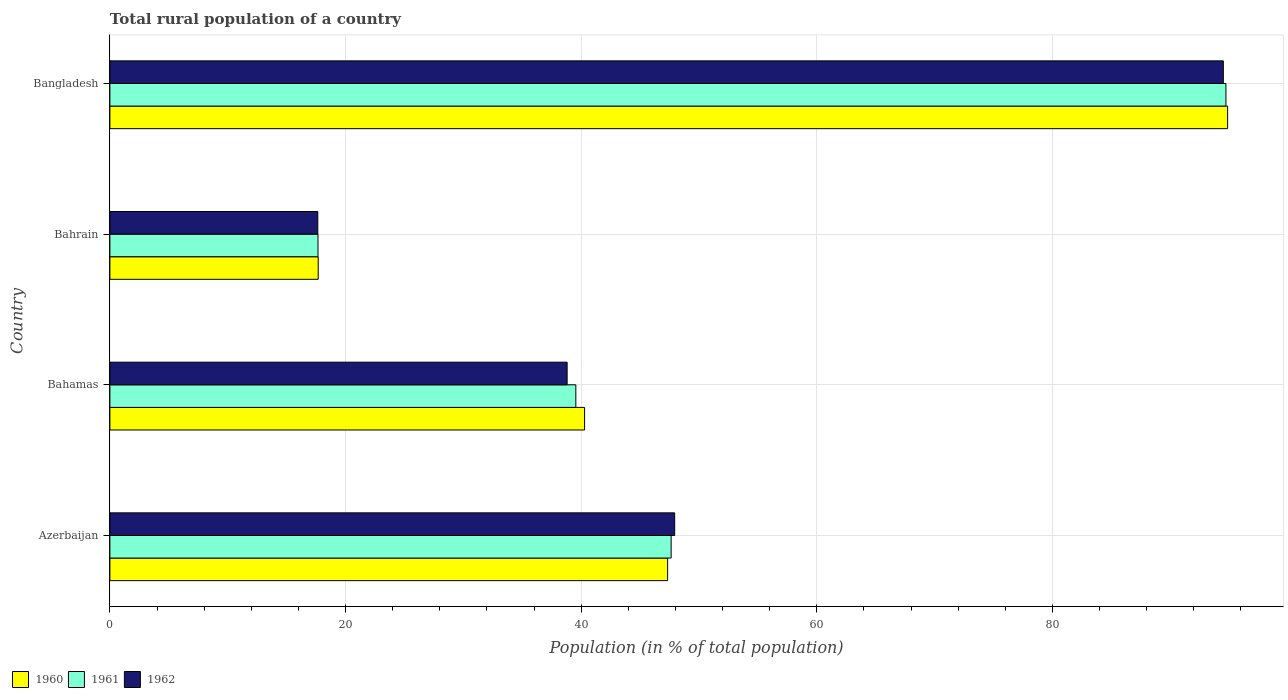How many different coloured bars are there?
Give a very brief answer. 3. How many groups of bars are there?
Keep it short and to the point. 4. Are the number of bars per tick equal to the number of legend labels?
Offer a terse response. Yes. How many bars are there on the 3rd tick from the top?
Provide a short and direct response. 3. How many bars are there on the 2nd tick from the bottom?
Your response must be concise. 3. What is the label of the 3rd group of bars from the top?
Provide a succinct answer. Bahamas. What is the rural population in 1961 in Azerbaijan?
Ensure brevity in your answer.  47.64. Across all countries, what is the maximum rural population in 1962?
Your answer should be very brief. 94.5. Across all countries, what is the minimum rural population in 1962?
Make the answer very short. 17.64. In which country was the rural population in 1960 minimum?
Your response must be concise. Bahrain. What is the total rural population in 1960 in the graph?
Your response must be concise. 200.17. What is the difference between the rural population in 1960 in Bahamas and that in Bahrain?
Provide a short and direct response. 22.61. What is the difference between the rural population in 1962 in Bahamas and the rural population in 1961 in Bahrain?
Your answer should be compact. 21.14. What is the average rural population in 1961 per country?
Offer a terse response. 49.89. What is the difference between the rural population in 1961 and rural population in 1960 in Azerbaijan?
Offer a terse response. 0.3. In how many countries, is the rural population in 1962 greater than 48 %?
Ensure brevity in your answer.  1. What is the ratio of the rural population in 1961 in Bahamas to that in Bahrain?
Keep it short and to the point. 2.24. Is the rural population in 1962 in Bahamas less than that in Bangladesh?
Provide a succinct answer. Yes. Is the difference between the rural population in 1961 in Bahamas and Bangladesh greater than the difference between the rural population in 1960 in Bahamas and Bangladesh?
Your answer should be compact. No. What is the difference between the highest and the second highest rural population in 1961?
Your response must be concise. 47.09. What is the difference between the highest and the lowest rural population in 1962?
Your response must be concise. 76.86. In how many countries, is the rural population in 1960 greater than the average rural population in 1960 taken over all countries?
Make the answer very short. 1. Is the sum of the rural population in 1960 in Bahrain and Bangladesh greater than the maximum rural population in 1962 across all countries?
Your answer should be very brief. Yes. Is it the case that in every country, the sum of the rural population in 1962 and rural population in 1960 is greater than the rural population in 1961?
Make the answer very short. Yes. Are all the bars in the graph horizontal?
Keep it short and to the point. Yes. Are the values on the major ticks of X-axis written in scientific E-notation?
Ensure brevity in your answer.  No. How are the legend labels stacked?
Offer a terse response. Horizontal. What is the title of the graph?
Provide a succinct answer. Total rural population of a country. Does "1975" appear as one of the legend labels in the graph?
Offer a very short reply. No. What is the label or title of the X-axis?
Ensure brevity in your answer.  Population (in % of total population). What is the label or title of the Y-axis?
Offer a very short reply. Country. What is the Population (in % of total population) in 1960 in Azerbaijan?
Make the answer very short. 47.34. What is the Population (in % of total population) in 1961 in Azerbaijan?
Keep it short and to the point. 47.64. What is the Population (in % of total population) in 1962 in Azerbaijan?
Make the answer very short. 47.94. What is the Population (in % of total population) in 1960 in Bahamas?
Ensure brevity in your answer.  40.29. What is the Population (in % of total population) in 1961 in Bahamas?
Make the answer very short. 39.55. What is the Population (in % of total population) in 1962 in Bahamas?
Offer a very short reply. 38.81. What is the Population (in % of total population) in 1960 in Bahrain?
Offer a terse response. 17.68. What is the Population (in % of total population) in 1961 in Bahrain?
Your answer should be very brief. 17.66. What is the Population (in % of total population) of 1962 in Bahrain?
Give a very brief answer. 17.64. What is the Population (in % of total population) of 1960 in Bangladesh?
Your response must be concise. 94.86. What is the Population (in % of total population) in 1961 in Bangladesh?
Your answer should be very brief. 94.72. What is the Population (in % of total population) of 1962 in Bangladesh?
Provide a short and direct response. 94.5. Across all countries, what is the maximum Population (in % of total population) of 1960?
Make the answer very short. 94.86. Across all countries, what is the maximum Population (in % of total population) of 1961?
Provide a succinct answer. 94.72. Across all countries, what is the maximum Population (in % of total population) of 1962?
Your answer should be compact. 94.5. Across all countries, what is the minimum Population (in % of total population) of 1960?
Your response must be concise. 17.68. Across all countries, what is the minimum Population (in % of total population) of 1961?
Provide a succinct answer. 17.66. Across all countries, what is the minimum Population (in % of total population) in 1962?
Offer a very short reply. 17.64. What is the total Population (in % of total population) of 1960 in the graph?
Provide a succinct answer. 200.17. What is the total Population (in % of total population) in 1961 in the graph?
Give a very brief answer. 199.57. What is the total Population (in % of total population) in 1962 in the graph?
Give a very brief answer. 198.89. What is the difference between the Population (in % of total population) of 1960 in Azerbaijan and that in Bahamas?
Offer a terse response. 7.05. What is the difference between the Population (in % of total population) of 1961 in Azerbaijan and that in Bahamas?
Your answer should be compact. 8.09. What is the difference between the Population (in % of total population) of 1962 in Azerbaijan and that in Bahamas?
Provide a short and direct response. 9.13. What is the difference between the Population (in % of total population) in 1960 in Azerbaijan and that in Bahrain?
Give a very brief answer. 29.66. What is the difference between the Population (in % of total population) of 1961 in Azerbaijan and that in Bahrain?
Ensure brevity in your answer.  29.97. What is the difference between the Population (in % of total population) of 1962 in Azerbaijan and that in Bahrain?
Your answer should be compact. 30.29. What is the difference between the Population (in % of total population) in 1960 in Azerbaijan and that in Bangladesh?
Provide a succinct answer. -47.53. What is the difference between the Population (in % of total population) of 1961 in Azerbaijan and that in Bangladesh?
Your response must be concise. -47.09. What is the difference between the Population (in % of total population) in 1962 in Azerbaijan and that in Bangladesh?
Your answer should be very brief. -46.57. What is the difference between the Population (in % of total population) in 1960 in Bahamas and that in Bahrain?
Provide a short and direct response. 22.61. What is the difference between the Population (in % of total population) in 1961 in Bahamas and that in Bahrain?
Provide a succinct answer. 21.88. What is the difference between the Population (in % of total population) in 1962 in Bahamas and that in Bahrain?
Provide a succinct answer. 21.16. What is the difference between the Population (in % of total population) of 1960 in Bahamas and that in Bangladesh?
Offer a terse response. -54.58. What is the difference between the Population (in % of total population) in 1961 in Bahamas and that in Bangladesh?
Keep it short and to the point. -55.18. What is the difference between the Population (in % of total population) in 1962 in Bahamas and that in Bangladesh?
Offer a terse response. -55.7. What is the difference between the Population (in % of total population) in 1960 in Bahrain and that in Bangladesh?
Offer a terse response. -77.19. What is the difference between the Population (in % of total population) in 1961 in Bahrain and that in Bangladesh?
Provide a short and direct response. -77.06. What is the difference between the Population (in % of total population) of 1962 in Bahrain and that in Bangladesh?
Give a very brief answer. -76.86. What is the difference between the Population (in % of total population) in 1960 in Azerbaijan and the Population (in % of total population) in 1961 in Bahamas?
Offer a terse response. 7.79. What is the difference between the Population (in % of total population) in 1960 in Azerbaijan and the Population (in % of total population) in 1962 in Bahamas?
Give a very brief answer. 8.53. What is the difference between the Population (in % of total population) of 1961 in Azerbaijan and the Population (in % of total population) of 1962 in Bahamas?
Your answer should be very brief. 8.83. What is the difference between the Population (in % of total population) in 1960 in Azerbaijan and the Population (in % of total population) in 1961 in Bahrain?
Provide a short and direct response. 29.67. What is the difference between the Population (in % of total population) of 1960 in Azerbaijan and the Population (in % of total population) of 1962 in Bahrain?
Your answer should be compact. 29.69. What is the difference between the Population (in % of total population) in 1961 in Azerbaijan and the Population (in % of total population) in 1962 in Bahrain?
Provide a short and direct response. 29.99. What is the difference between the Population (in % of total population) of 1960 in Azerbaijan and the Population (in % of total population) of 1961 in Bangladesh?
Your answer should be very brief. -47.38. What is the difference between the Population (in % of total population) in 1960 in Azerbaijan and the Population (in % of total population) in 1962 in Bangladesh?
Give a very brief answer. -47.16. What is the difference between the Population (in % of total population) in 1961 in Azerbaijan and the Population (in % of total population) in 1962 in Bangladesh?
Make the answer very short. -46.87. What is the difference between the Population (in % of total population) of 1960 in Bahamas and the Population (in % of total population) of 1961 in Bahrain?
Your answer should be very brief. 22.62. What is the difference between the Population (in % of total population) in 1960 in Bahamas and the Population (in % of total population) in 1962 in Bahrain?
Your response must be concise. 22.64. What is the difference between the Population (in % of total population) in 1961 in Bahamas and the Population (in % of total population) in 1962 in Bahrain?
Provide a short and direct response. 21.9. What is the difference between the Population (in % of total population) in 1960 in Bahamas and the Population (in % of total population) in 1961 in Bangladesh?
Your answer should be compact. -54.43. What is the difference between the Population (in % of total population) of 1960 in Bahamas and the Population (in % of total population) of 1962 in Bangladesh?
Provide a succinct answer. -54.21. What is the difference between the Population (in % of total population) of 1961 in Bahamas and the Population (in % of total population) of 1962 in Bangladesh?
Offer a terse response. -54.96. What is the difference between the Population (in % of total population) in 1960 in Bahrain and the Population (in % of total population) in 1961 in Bangladesh?
Make the answer very short. -77.04. What is the difference between the Population (in % of total population) in 1960 in Bahrain and the Population (in % of total population) in 1962 in Bangladesh?
Your response must be concise. -76.82. What is the difference between the Population (in % of total population) in 1961 in Bahrain and the Population (in % of total population) in 1962 in Bangladesh?
Make the answer very short. -76.84. What is the average Population (in % of total population) of 1960 per country?
Provide a succinct answer. 50.04. What is the average Population (in % of total population) of 1961 per country?
Your answer should be compact. 49.89. What is the average Population (in % of total population) in 1962 per country?
Make the answer very short. 49.72. What is the difference between the Population (in % of total population) of 1960 and Population (in % of total population) of 1961 in Azerbaijan?
Keep it short and to the point. -0.3. What is the difference between the Population (in % of total population) in 1960 and Population (in % of total population) in 1962 in Azerbaijan?
Give a very brief answer. -0.6. What is the difference between the Population (in % of total population) of 1961 and Population (in % of total population) of 1962 in Azerbaijan?
Keep it short and to the point. -0.3. What is the difference between the Population (in % of total population) in 1960 and Population (in % of total population) in 1961 in Bahamas?
Make the answer very short. 0.74. What is the difference between the Population (in % of total population) in 1960 and Population (in % of total population) in 1962 in Bahamas?
Your answer should be compact. 1.48. What is the difference between the Population (in % of total population) of 1961 and Population (in % of total population) of 1962 in Bahamas?
Make the answer very short. 0.74. What is the difference between the Population (in % of total population) of 1960 and Population (in % of total population) of 1961 in Bahrain?
Provide a succinct answer. 0.02. What is the difference between the Population (in % of total population) of 1960 and Population (in % of total population) of 1962 in Bahrain?
Provide a succinct answer. 0.04. What is the difference between the Population (in % of total population) in 1961 and Population (in % of total population) in 1962 in Bahrain?
Your response must be concise. 0.02. What is the difference between the Population (in % of total population) in 1960 and Population (in % of total population) in 1961 in Bangladesh?
Provide a succinct answer. 0.14. What is the difference between the Population (in % of total population) in 1960 and Population (in % of total population) in 1962 in Bangladesh?
Provide a short and direct response. 0.36. What is the difference between the Population (in % of total population) in 1961 and Population (in % of total population) in 1962 in Bangladesh?
Your response must be concise. 0.22. What is the ratio of the Population (in % of total population) of 1960 in Azerbaijan to that in Bahamas?
Provide a succinct answer. 1.18. What is the ratio of the Population (in % of total population) in 1961 in Azerbaijan to that in Bahamas?
Provide a succinct answer. 1.2. What is the ratio of the Population (in % of total population) in 1962 in Azerbaijan to that in Bahamas?
Offer a terse response. 1.24. What is the ratio of the Population (in % of total population) in 1960 in Azerbaijan to that in Bahrain?
Offer a very short reply. 2.68. What is the ratio of the Population (in % of total population) of 1961 in Azerbaijan to that in Bahrain?
Offer a very short reply. 2.7. What is the ratio of the Population (in % of total population) of 1962 in Azerbaijan to that in Bahrain?
Your answer should be compact. 2.72. What is the ratio of the Population (in % of total population) of 1960 in Azerbaijan to that in Bangladesh?
Ensure brevity in your answer.  0.5. What is the ratio of the Population (in % of total population) of 1961 in Azerbaijan to that in Bangladesh?
Ensure brevity in your answer.  0.5. What is the ratio of the Population (in % of total population) in 1962 in Azerbaijan to that in Bangladesh?
Offer a very short reply. 0.51. What is the ratio of the Population (in % of total population) of 1960 in Bahamas to that in Bahrain?
Your answer should be compact. 2.28. What is the ratio of the Population (in % of total population) of 1961 in Bahamas to that in Bahrain?
Provide a succinct answer. 2.24. What is the ratio of the Population (in % of total population) in 1962 in Bahamas to that in Bahrain?
Your answer should be compact. 2.2. What is the ratio of the Population (in % of total population) of 1960 in Bahamas to that in Bangladesh?
Make the answer very short. 0.42. What is the ratio of the Population (in % of total population) of 1961 in Bahamas to that in Bangladesh?
Provide a succinct answer. 0.42. What is the ratio of the Population (in % of total population) in 1962 in Bahamas to that in Bangladesh?
Give a very brief answer. 0.41. What is the ratio of the Population (in % of total population) in 1960 in Bahrain to that in Bangladesh?
Ensure brevity in your answer.  0.19. What is the ratio of the Population (in % of total population) of 1961 in Bahrain to that in Bangladesh?
Ensure brevity in your answer.  0.19. What is the ratio of the Population (in % of total population) in 1962 in Bahrain to that in Bangladesh?
Provide a succinct answer. 0.19. What is the difference between the highest and the second highest Population (in % of total population) of 1960?
Give a very brief answer. 47.53. What is the difference between the highest and the second highest Population (in % of total population) in 1961?
Offer a terse response. 47.09. What is the difference between the highest and the second highest Population (in % of total population) in 1962?
Your answer should be compact. 46.57. What is the difference between the highest and the lowest Population (in % of total population) in 1960?
Give a very brief answer. 77.19. What is the difference between the highest and the lowest Population (in % of total population) in 1961?
Ensure brevity in your answer.  77.06. What is the difference between the highest and the lowest Population (in % of total population) of 1962?
Your answer should be compact. 76.86. 